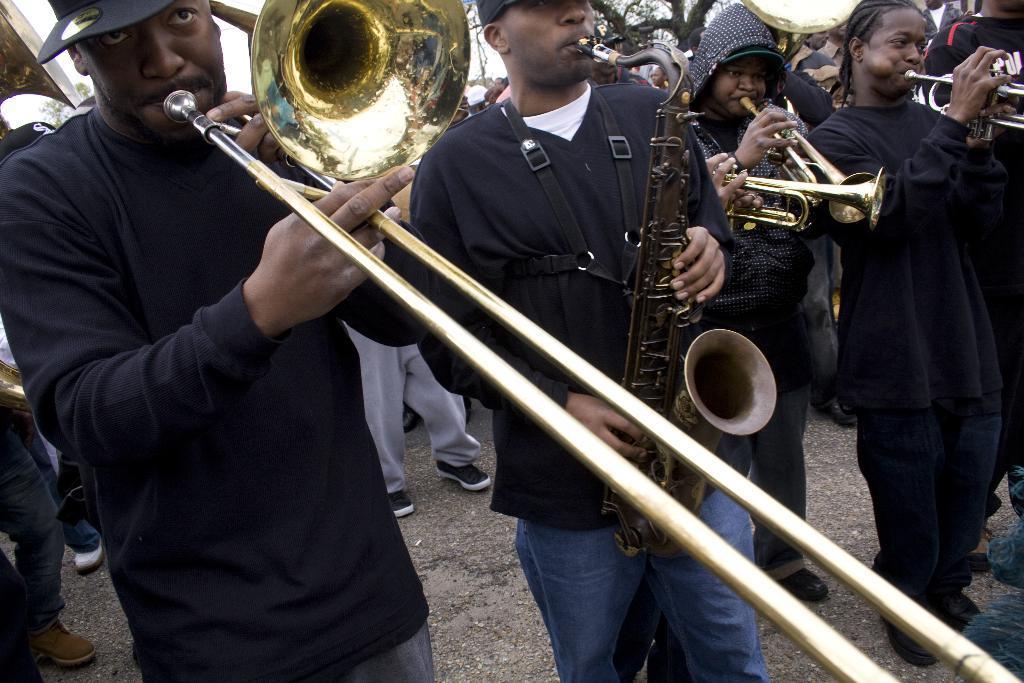In one or two sentences, can you explain what this image depicts? In this image there are group of people standing and holding saxophone, trombone and trumpets , and in the background there are group of people , there is a tree and sky. 